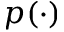Convert formula to latex. <formula><loc_0><loc_0><loc_500><loc_500>p ( \cdot )</formula> 